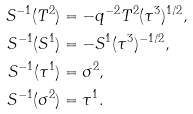<formula> <loc_0><loc_0><loc_500><loc_500>S ^ { - 1 } ( T ^ { 2 } ) & = - q ^ { - 2 } T ^ { 2 } ( \tau ^ { 3 } ) ^ { 1 / 2 } , \\ S ^ { - 1 } ( S ^ { 1 } ) & = - S ^ { 1 } ( \tau ^ { 3 } ) ^ { - 1 / 2 } , \\ S ^ { - 1 } ( \tau ^ { 1 } ) & = \sigma ^ { 2 } , \\ S ^ { - 1 } ( \sigma ^ { 2 } ) & = \tau ^ { 1 } .</formula> 